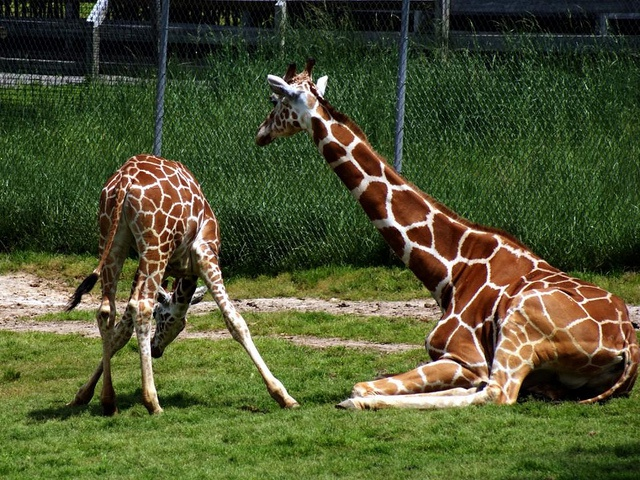Describe the objects in this image and their specific colors. I can see giraffe in black, maroon, brown, and ivory tones and giraffe in black, olive, maroon, and white tones in this image. 